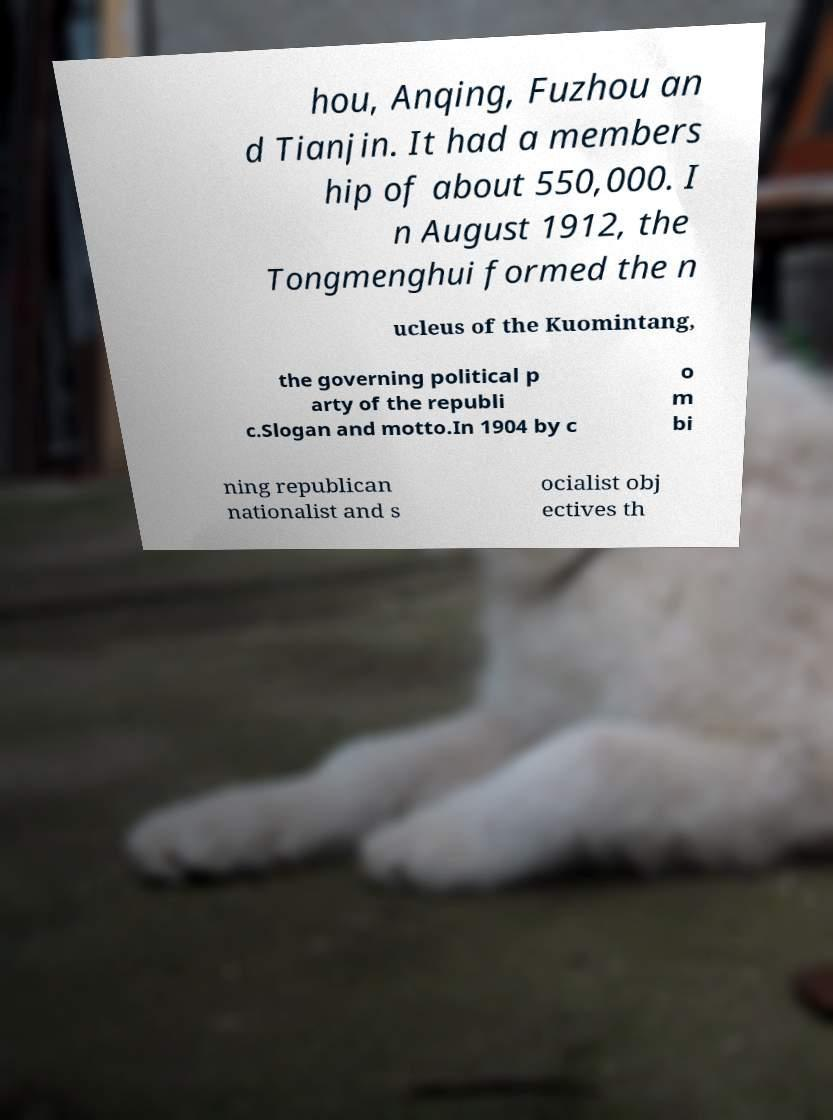Could you assist in decoding the text presented in this image and type it out clearly? hou, Anqing, Fuzhou an d Tianjin. It had a members hip of about 550,000. I n August 1912, the Tongmenghui formed the n ucleus of the Kuomintang, the governing political p arty of the republi c.Slogan and motto.In 1904 by c o m bi ning republican nationalist and s ocialist obj ectives th 